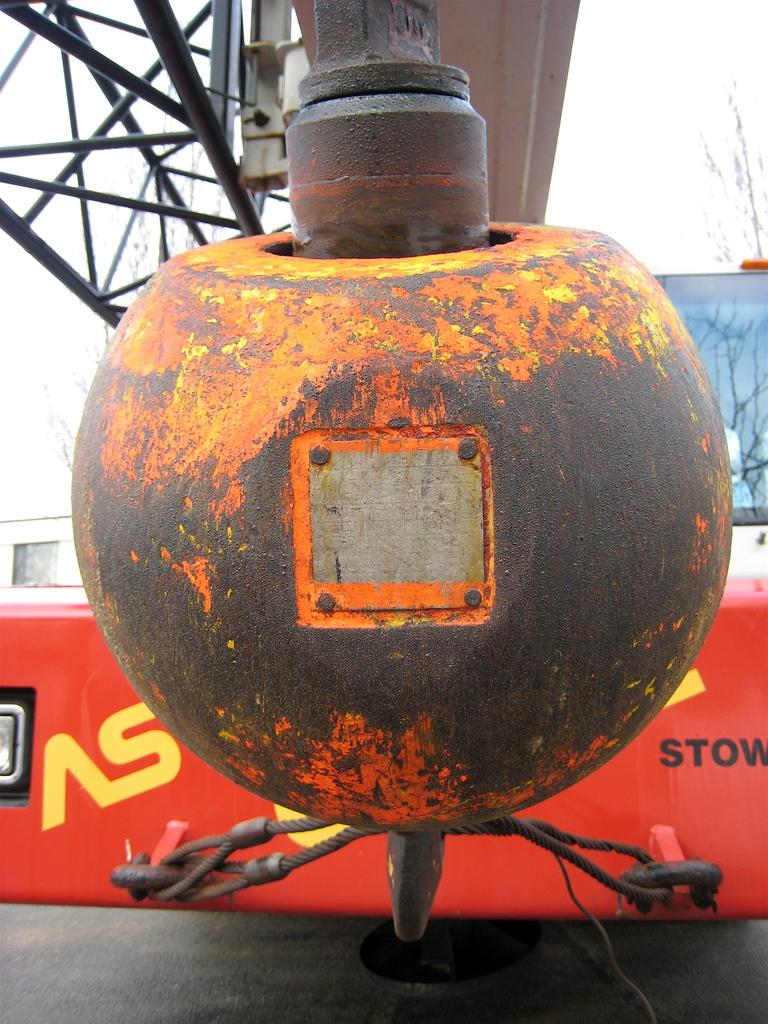What can be seen on the right side of the image? There is a vehicle on the right side of the image. What type of natural elements are present in the image? There are trees in the image. What is visible in the background of the image? The sky is visible in the image. Can you describe any other objects in the image? There are unspecified objects in the image. What type of soup is being served in the image? There is no soup present in the image. How many clovers can be seen growing in the image? There is no mention of clovers in the image, so it is impossible to determine their presence or quantity. 